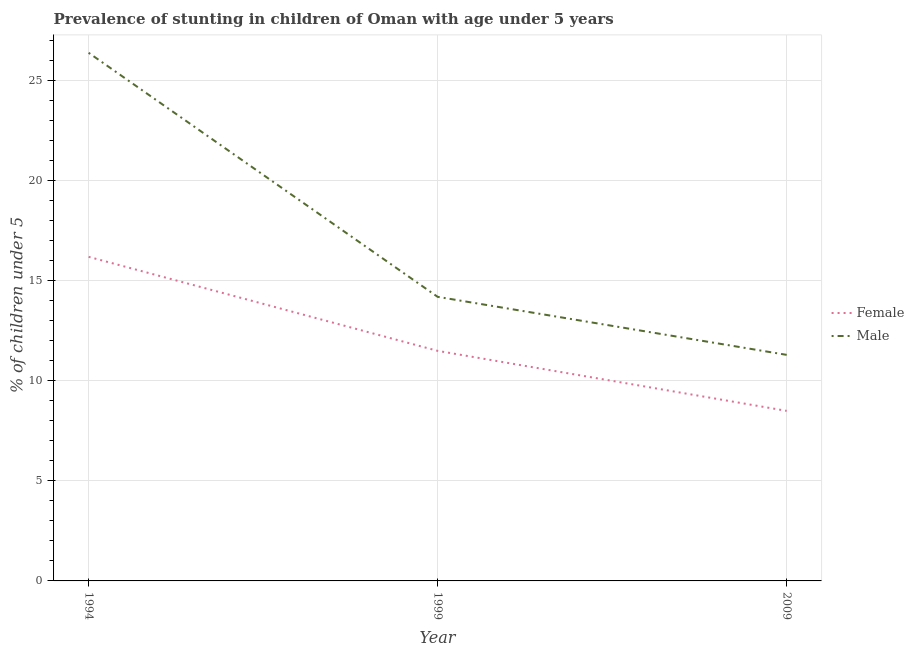Does the line corresponding to percentage of stunted female children intersect with the line corresponding to percentage of stunted male children?
Provide a succinct answer. No. Is the number of lines equal to the number of legend labels?
Your answer should be compact. Yes. What is the percentage of stunted female children in 1999?
Give a very brief answer. 11.5. Across all years, what is the maximum percentage of stunted male children?
Offer a terse response. 26.4. Across all years, what is the minimum percentage of stunted male children?
Provide a short and direct response. 11.3. In which year was the percentage of stunted female children maximum?
Give a very brief answer. 1994. In which year was the percentage of stunted male children minimum?
Your answer should be very brief. 2009. What is the total percentage of stunted female children in the graph?
Your response must be concise. 36.2. What is the difference between the percentage of stunted male children in 1994 and that in 2009?
Your response must be concise. 15.1. What is the difference between the percentage of stunted female children in 2009 and the percentage of stunted male children in 1994?
Keep it short and to the point. -17.9. What is the average percentage of stunted female children per year?
Give a very brief answer. 12.07. In the year 1999, what is the difference between the percentage of stunted male children and percentage of stunted female children?
Provide a short and direct response. 2.7. In how many years, is the percentage of stunted female children greater than 3 %?
Give a very brief answer. 3. What is the ratio of the percentage of stunted male children in 1999 to that in 2009?
Your answer should be very brief. 1.26. Is the percentage of stunted female children in 1999 less than that in 2009?
Your response must be concise. No. What is the difference between the highest and the second highest percentage of stunted male children?
Make the answer very short. 12.2. What is the difference between the highest and the lowest percentage of stunted female children?
Your answer should be compact. 7.7. In how many years, is the percentage of stunted female children greater than the average percentage of stunted female children taken over all years?
Make the answer very short. 1. Is the sum of the percentage of stunted male children in 1994 and 2009 greater than the maximum percentage of stunted female children across all years?
Your answer should be very brief. Yes. Is the percentage of stunted male children strictly greater than the percentage of stunted female children over the years?
Your answer should be compact. Yes. Is the percentage of stunted female children strictly less than the percentage of stunted male children over the years?
Give a very brief answer. Yes. How many lines are there?
Make the answer very short. 2. How many years are there in the graph?
Offer a very short reply. 3. What is the difference between two consecutive major ticks on the Y-axis?
Make the answer very short. 5. Does the graph contain any zero values?
Your answer should be compact. No. Where does the legend appear in the graph?
Ensure brevity in your answer.  Center right. How many legend labels are there?
Offer a terse response. 2. What is the title of the graph?
Offer a terse response. Prevalence of stunting in children of Oman with age under 5 years. What is the label or title of the X-axis?
Ensure brevity in your answer.  Year. What is the label or title of the Y-axis?
Offer a very short reply.  % of children under 5. What is the  % of children under 5 in Female in 1994?
Make the answer very short. 16.2. What is the  % of children under 5 of Male in 1994?
Ensure brevity in your answer.  26.4. What is the  % of children under 5 in Female in 1999?
Your answer should be very brief. 11.5. What is the  % of children under 5 in Male in 1999?
Ensure brevity in your answer.  14.2. What is the  % of children under 5 in Male in 2009?
Your answer should be very brief. 11.3. Across all years, what is the maximum  % of children under 5 in Female?
Offer a very short reply. 16.2. Across all years, what is the maximum  % of children under 5 of Male?
Provide a short and direct response. 26.4. Across all years, what is the minimum  % of children under 5 in Female?
Make the answer very short. 8.5. Across all years, what is the minimum  % of children under 5 in Male?
Offer a terse response. 11.3. What is the total  % of children under 5 of Female in the graph?
Keep it short and to the point. 36.2. What is the total  % of children under 5 of Male in the graph?
Offer a very short reply. 51.9. What is the difference between the  % of children under 5 of Female in 1994 and that in 2009?
Give a very brief answer. 7.7. What is the difference between the  % of children under 5 of Male in 1994 and that in 2009?
Provide a short and direct response. 15.1. What is the difference between the  % of children under 5 of Female in 1994 and the  % of children under 5 of Male in 1999?
Your answer should be very brief. 2. What is the average  % of children under 5 of Female per year?
Offer a terse response. 12.07. What is the average  % of children under 5 in Male per year?
Your response must be concise. 17.3. What is the ratio of the  % of children under 5 of Female in 1994 to that in 1999?
Provide a succinct answer. 1.41. What is the ratio of the  % of children under 5 of Male in 1994 to that in 1999?
Give a very brief answer. 1.86. What is the ratio of the  % of children under 5 in Female in 1994 to that in 2009?
Offer a terse response. 1.91. What is the ratio of the  % of children under 5 of Male in 1994 to that in 2009?
Give a very brief answer. 2.34. What is the ratio of the  % of children under 5 of Female in 1999 to that in 2009?
Ensure brevity in your answer.  1.35. What is the ratio of the  % of children under 5 in Male in 1999 to that in 2009?
Provide a short and direct response. 1.26. What is the difference between the highest and the lowest  % of children under 5 in Male?
Your answer should be compact. 15.1. 